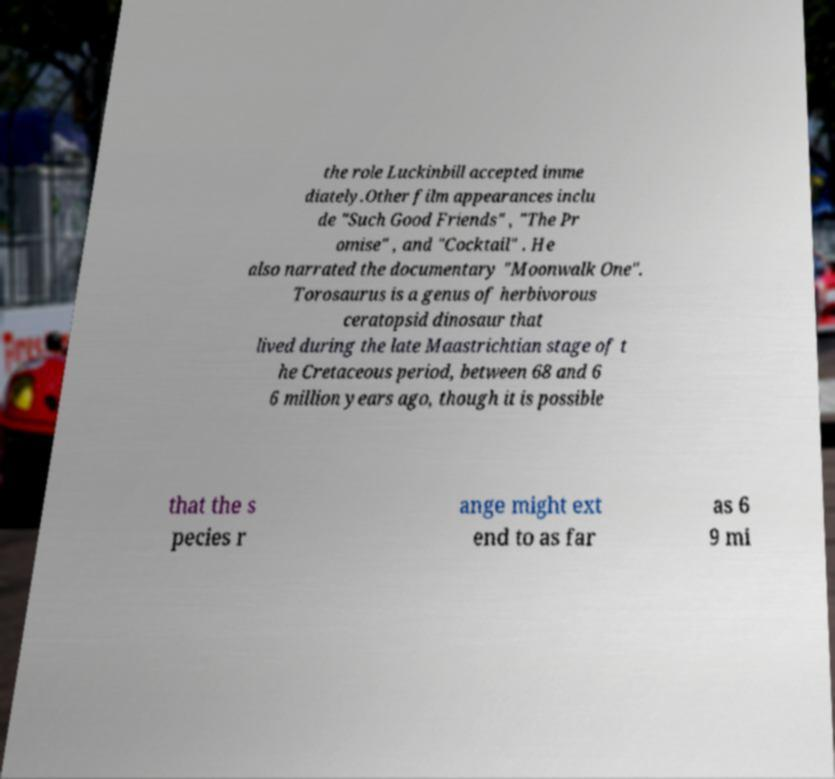What messages or text are displayed in this image? I need them in a readable, typed format. the role Luckinbill accepted imme diately.Other film appearances inclu de "Such Good Friends" , "The Pr omise" , and "Cocktail" . He also narrated the documentary "Moonwalk One". Torosaurus is a genus of herbivorous ceratopsid dinosaur that lived during the late Maastrichtian stage of t he Cretaceous period, between 68 and 6 6 million years ago, though it is possible that the s pecies r ange might ext end to as far as 6 9 mi 